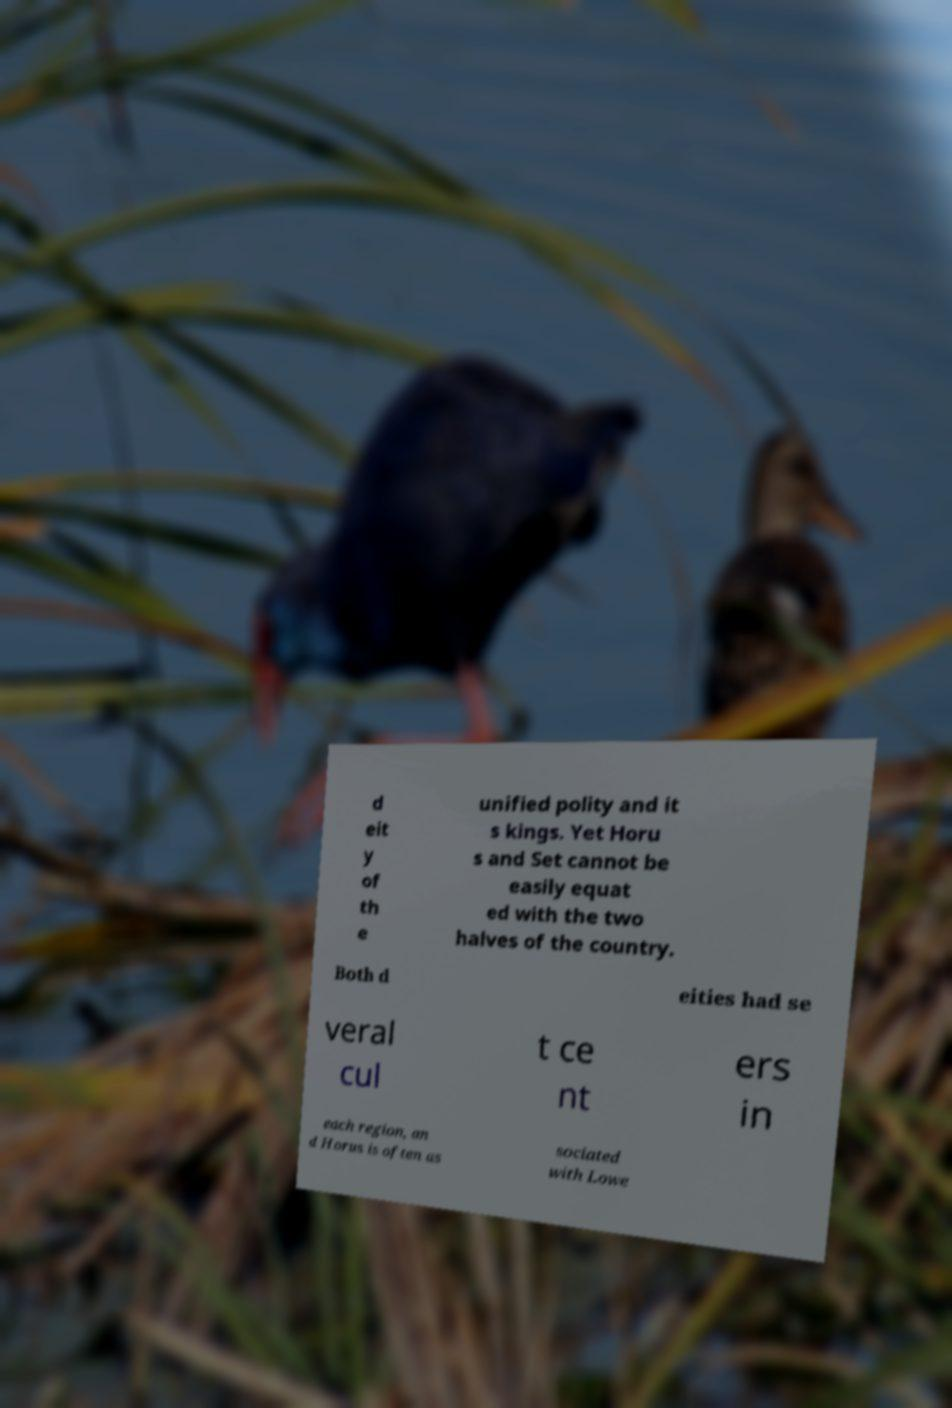What messages or text are displayed in this image? I need them in a readable, typed format. d eit y of th e unified polity and it s kings. Yet Horu s and Set cannot be easily equat ed with the two halves of the country. Both d eities had se veral cul t ce nt ers in each region, an d Horus is often as sociated with Lowe 